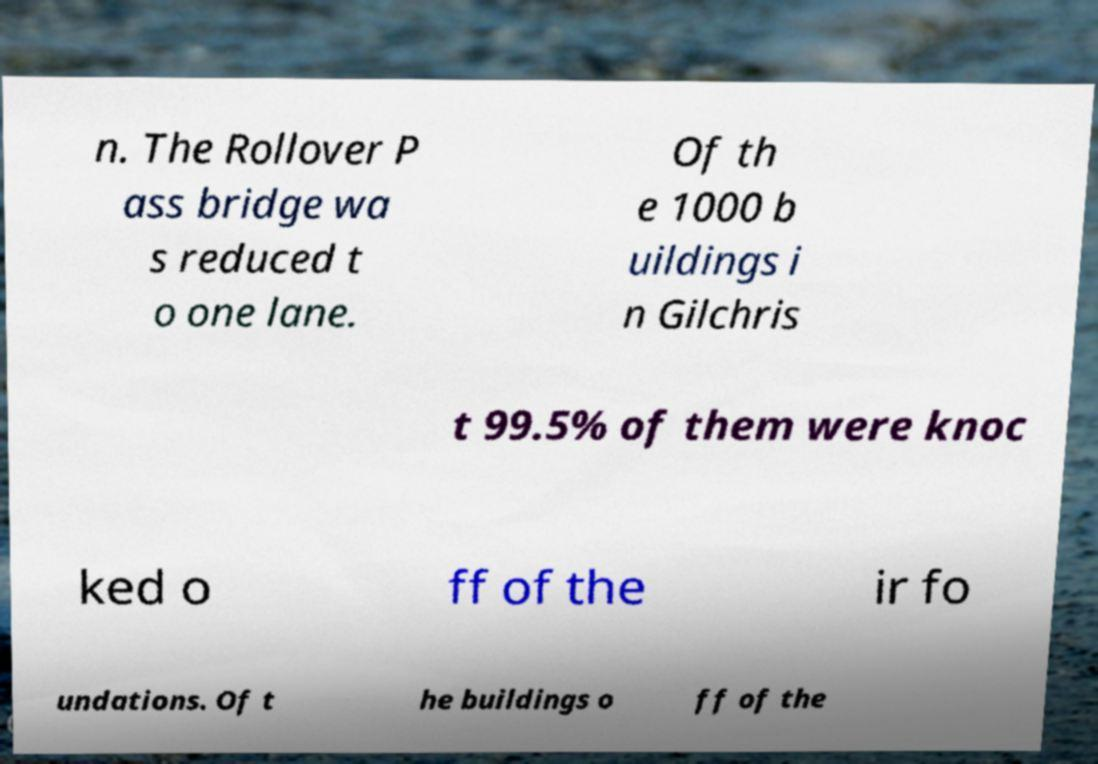Can you read and provide the text displayed in the image?This photo seems to have some interesting text. Can you extract and type it out for me? n. The Rollover P ass bridge wa s reduced t o one lane. Of th e 1000 b uildings i n Gilchris t 99.5% of them were knoc ked o ff of the ir fo undations. Of t he buildings o ff of the 